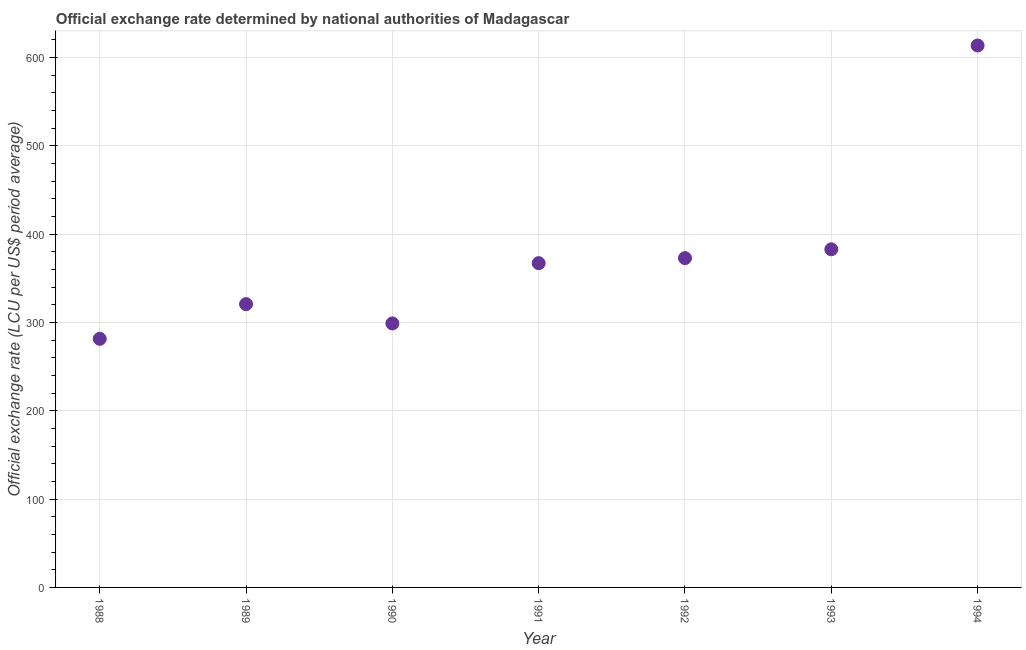What is the official exchange rate in 1988?
Keep it short and to the point. 281.42. Across all years, what is the maximum official exchange rate?
Offer a very short reply. 613.47. Across all years, what is the minimum official exchange rate?
Your answer should be compact. 281.42. In which year was the official exchange rate maximum?
Offer a very short reply. 1994. What is the sum of the official exchange rate?
Your response must be concise. 2637.03. What is the difference between the official exchange rate in 1989 and 1994?
Your answer should be very brief. -292.78. What is the average official exchange rate per year?
Your answer should be very brief. 376.72. What is the median official exchange rate?
Your response must be concise. 367.07. What is the ratio of the official exchange rate in 1988 to that in 1989?
Keep it short and to the point. 0.88. Is the official exchange rate in 1990 less than that in 1991?
Ensure brevity in your answer.  Yes. Is the difference between the official exchange rate in 1988 and 1994 greater than the difference between any two years?
Offer a terse response. Yes. What is the difference between the highest and the second highest official exchange rate?
Make the answer very short. 230.71. What is the difference between the highest and the lowest official exchange rate?
Provide a succinct answer. 332.05. Are the values on the major ticks of Y-axis written in scientific E-notation?
Offer a terse response. No. Does the graph contain grids?
Make the answer very short. Yes. What is the title of the graph?
Give a very brief answer. Official exchange rate determined by national authorities of Madagascar. What is the label or title of the X-axis?
Your answer should be very brief. Year. What is the label or title of the Y-axis?
Provide a short and direct response. Official exchange rate (LCU per US$ period average). What is the Official exchange rate (LCU per US$ period average) in 1988?
Your response must be concise. 281.42. What is the Official exchange rate (LCU per US$ period average) in 1989?
Provide a succinct answer. 320.69. What is the Official exchange rate (LCU per US$ period average) in 1990?
Provide a short and direct response. 298.83. What is the Official exchange rate (LCU per US$ period average) in 1991?
Offer a very short reply. 367.07. What is the Official exchange rate (LCU per US$ period average) in 1992?
Keep it short and to the point. 372.79. What is the Official exchange rate (LCU per US$ period average) in 1993?
Provide a short and direct response. 382.76. What is the Official exchange rate (LCU per US$ period average) in 1994?
Ensure brevity in your answer.  613.47. What is the difference between the Official exchange rate (LCU per US$ period average) in 1988 and 1989?
Your answer should be very brief. -39.27. What is the difference between the Official exchange rate (LCU per US$ period average) in 1988 and 1990?
Provide a succinct answer. -17.41. What is the difference between the Official exchange rate (LCU per US$ period average) in 1988 and 1991?
Ensure brevity in your answer.  -85.65. What is the difference between the Official exchange rate (LCU per US$ period average) in 1988 and 1992?
Offer a terse response. -91.37. What is the difference between the Official exchange rate (LCU per US$ period average) in 1988 and 1993?
Your response must be concise. -101.34. What is the difference between the Official exchange rate (LCU per US$ period average) in 1988 and 1994?
Offer a terse response. -332.05. What is the difference between the Official exchange rate (LCU per US$ period average) in 1989 and 1990?
Provide a succinct answer. 21.86. What is the difference between the Official exchange rate (LCU per US$ period average) in 1989 and 1991?
Give a very brief answer. -46.38. What is the difference between the Official exchange rate (LCU per US$ period average) in 1989 and 1992?
Make the answer very short. -52.11. What is the difference between the Official exchange rate (LCU per US$ period average) in 1989 and 1993?
Your response must be concise. -62.07. What is the difference between the Official exchange rate (LCU per US$ period average) in 1989 and 1994?
Your response must be concise. -292.78. What is the difference between the Official exchange rate (LCU per US$ period average) in 1990 and 1991?
Make the answer very short. -68.24. What is the difference between the Official exchange rate (LCU per US$ period average) in 1990 and 1992?
Offer a terse response. -73.96. What is the difference between the Official exchange rate (LCU per US$ period average) in 1990 and 1993?
Your answer should be compact. -83.93. What is the difference between the Official exchange rate (LCU per US$ period average) in 1990 and 1994?
Your answer should be very brief. -314.64. What is the difference between the Official exchange rate (LCU per US$ period average) in 1991 and 1992?
Offer a very short reply. -5.72. What is the difference between the Official exchange rate (LCU per US$ period average) in 1991 and 1993?
Your answer should be very brief. -15.68. What is the difference between the Official exchange rate (LCU per US$ period average) in 1991 and 1994?
Give a very brief answer. -246.4. What is the difference between the Official exchange rate (LCU per US$ period average) in 1992 and 1993?
Ensure brevity in your answer.  -9.96. What is the difference between the Official exchange rate (LCU per US$ period average) in 1992 and 1994?
Offer a very short reply. -240.67. What is the difference between the Official exchange rate (LCU per US$ period average) in 1993 and 1994?
Ensure brevity in your answer.  -230.71. What is the ratio of the Official exchange rate (LCU per US$ period average) in 1988 to that in 1989?
Your answer should be compact. 0.88. What is the ratio of the Official exchange rate (LCU per US$ period average) in 1988 to that in 1990?
Provide a short and direct response. 0.94. What is the ratio of the Official exchange rate (LCU per US$ period average) in 1988 to that in 1991?
Offer a terse response. 0.77. What is the ratio of the Official exchange rate (LCU per US$ period average) in 1988 to that in 1992?
Offer a terse response. 0.76. What is the ratio of the Official exchange rate (LCU per US$ period average) in 1988 to that in 1993?
Keep it short and to the point. 0.73. What is the ratio of the Official exchange rate (LCU per US$ period average) in 1988 to that in 1994?
Offer a very short reply. 0.46. What is the ratio of the Official exchange rate (LCU per US$ period average) in 1989 to that in 1990?
Provide a succinct answer. 1.07. What is the ratio of the Official exchange rate (LCU per US$ period average) in 1989 to that in 1991?
Provide a short and direct response. 0.87. What is the ratio of the Official exchange rate (LCU per US$ period average) in 1989 to that in 1992?
Ensure brevity in your answer.  0.86. What is the ratio of the Official exchange rate (LCU per US$ period average) in 1989 to that in 1993?
Offer a very short reply. 0.84. What is the ratio of the Official exchange rate (LCU per US$ period average) in 1989 to that in 1994?
Offer a terse response. 0.52. What is the ratio of the Official exchange rate (LCU per US$ period average) in 1990 to that in 1991?
Your answer should be very brief. 0.81. What is the ratio of the Official exchange rate (LCU per US$ period average) in 1990 to that in 1992?
Provide a succinct answer. 0.8. What is the ratio of the Official exchange rate (LCU per US$ period average) in 1990 to that in 1993?
Keep it short and to the point. 0.78. What is the ratio of the Official exchange rate (LCU per US$ period average) in 1990 to that in 1994?
Provide a succinct answer. 0.49. What is the ratio of the Official exchange rate (LCU per US$ period average) in 1991 to that in 1992?
Give a very brief answer. 0.98. What is the ratio of the Official exchange rate (LCU per US$ period average) in 1991 to that in 1993?
Provide a succinct answer. 0.96. What is the ratio of the Official exchange rate (LCU per US$ period average) in 1991 to that in 1994?
Provide a succinct answer. 0.6. What is the ratio of the Official exchange rate (LCU per US$ period average) in 1992 to that in 1993?
Give a very brief answer. 0.97. What is the ratio of the Official exchange rate (LCU per US$ period average) in 1992 to that in 1994?
Give a very brief answer. 0.61. What is the ratio of the Official exchange rate (LCU per US$ period average) in 1993 to that in 1994?
Your answer should be compact. 0.62. 